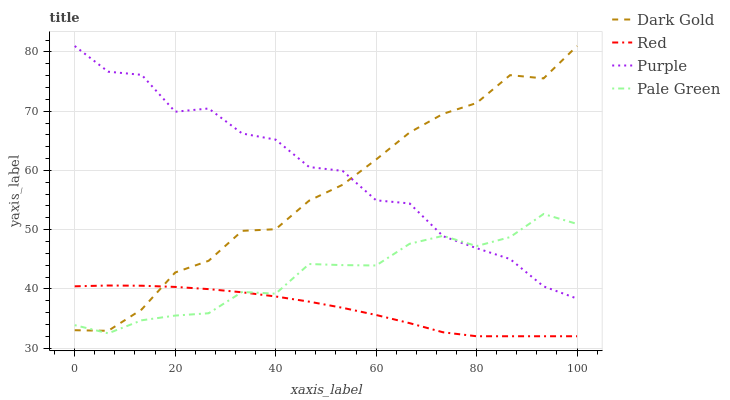Does Red have the minimum area under the curve?
Answer yes or no. Yes. Does Purple have the maximum area under the curve?
Answer yes or no. Yes. Does Pale Green have the minimum area under the curve?
Answer yes or no. No. Does Pale Green have the maximum area under the curve?
Answer yes or no. No. Is Red the smoothest?
Answer yes or no. Yes. Is Purple the roughest?
Answer yes or no. Yes. Is Pale Green the smoothest?
Answer yes or no. No. Is Pale Green the roughest?
Answer yes or no. No. Does Red have the lowest value?
Answer yes or no. Yes. Does Pale Green have the lowest value?
Answer yes or no. No. Does Dark Gold have the highest value?
Answer yes or no. Yes. Does Pale Green have the highest value?
Answer yes or no. No. Is Red less than Purple?
Answer yes or no. Yes. Is Purple greater than Red?
Answer yes or no. Yes. Does Pale Green intersect Dark Gold?
Answer yes or no. Yes. Is Pale Green less than Dark Gold?
Answer yes or no. No. Is Pale Green greater than Dark Gold?
Answer yes or no. No. Does Red intersect Purple?
Answer yes or no. No. 